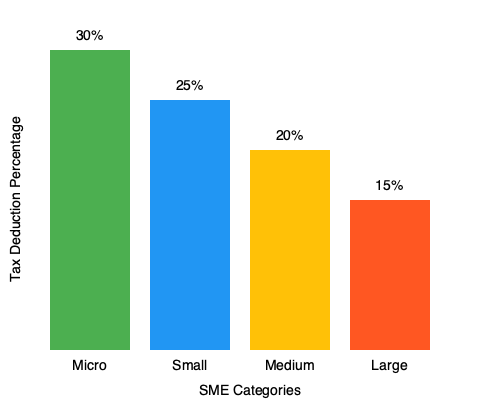Based on the bar chart showing tax deduction percentages for different SME categories, calculate the difference in tax savings between a Micro SME and a Medium SME if both have a taxable income of $500,000. Assume the tax rate is 20% before deductions. To solve this problem, we need to follow these steps:

1. Identify the tax deduction percentages for Micro and Medium SMEs:
   - Micro SME: 30%
   - Medium SME: 20%

2. Calculate the taxable income after deductions for each category:
   - Micro SME: $500,000 * (1 - 0.30) = $350,000
   - Medium SME: $500,000 * (1 - 0.20) = $400,000

3. Calculate the tax owed for each category (20% tax rate):
   - Micro SME: $350,000 * 0.20 = $70,000
   - Medium SME: $400,000 * 0.20 = $80,000

4. Calculate the tax savings for each category:
   - Micro SME: $500,000 * 0.20 - $70,000 = $30,000
   - Medium SME: $500,000 * 0.20 - $80,000 = $20,000

5. Calculate the difference in tax savings:
   $30,000 - $20,000 = $10,000

Therefore, the difference in tax savings between a Micro SME and a Medium SME with a taxable income of $500,000 is $10,000.
Answer: $10,000 